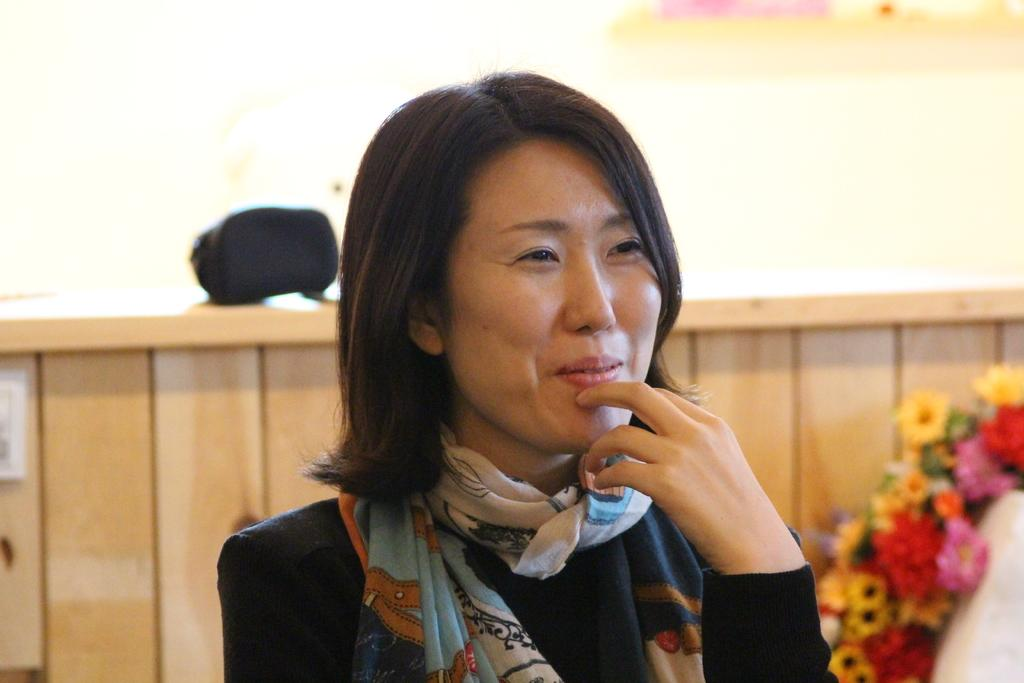Who is in the image? There is a person in the image. What is the person doing in the image? The person is smiling. What can be seen in the background of the image? There is brown fencing and colorful flowers in the background of the image. What type of test is the person taking in the image? There is no indication in the image that the person is taking a test, as they are simply smiling. Can you provide me with a list of the person's favorite hobbies based on the image? The image does not provide any information about the person's hobbies, so it is not possible to create a list of their favorite hobbies. 